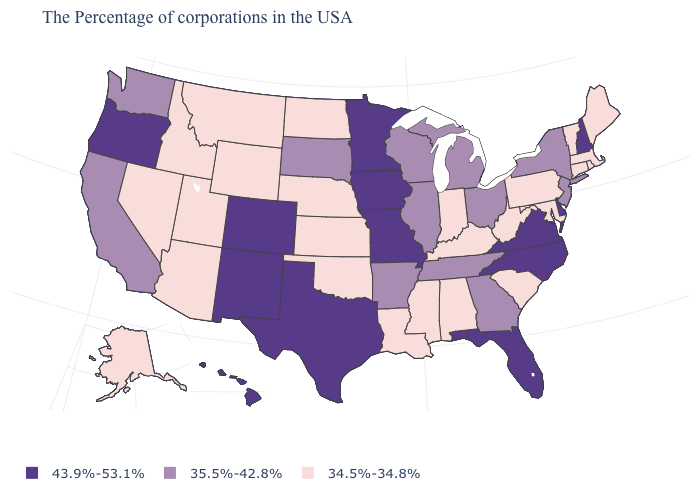Does North Carolina have the highest value in the USA?
Quick response, please. Yes. What is the value of Minnesota?
Quick response, please. 43.9%-53.1%. Which states hav the highest value in the MidWest?
Short answer required. Missouri, Minnesota, Iowa. What is the value of Washington?
Short answer required. 35.5%-42.8%. Does Alaska have the highest value in the West?
Concise answer only. No. Among the states that border Kentucky , which have the lowest value?
Keep it brief. West Virginia, Indiana. Does West Virginia have the highest value in the South?
Concise answer only. No. What is the value of Delaware?
Give a very brief answer. 43.9%-53.1%. Is the legend a continuous bar?
Answer briefly. No. Is the legend a continuous bar?
Concise answer only. No. What is the value of Arizona?
Short answer required. 34.5%-34.8%. Which states hav the highest value in the South?
Give a very brief answer. Delaware, Virginia, North Carolina, Florida, Texas. Among the states that border Nebraska , does Missouri have the highest value?
Quick response, please. Yes. Does Connecticut have the lowest value in the Northeast?
Give a very brief answer. Yes. What is the value of California?
Concise answer only. 35.5%-42.8%. 